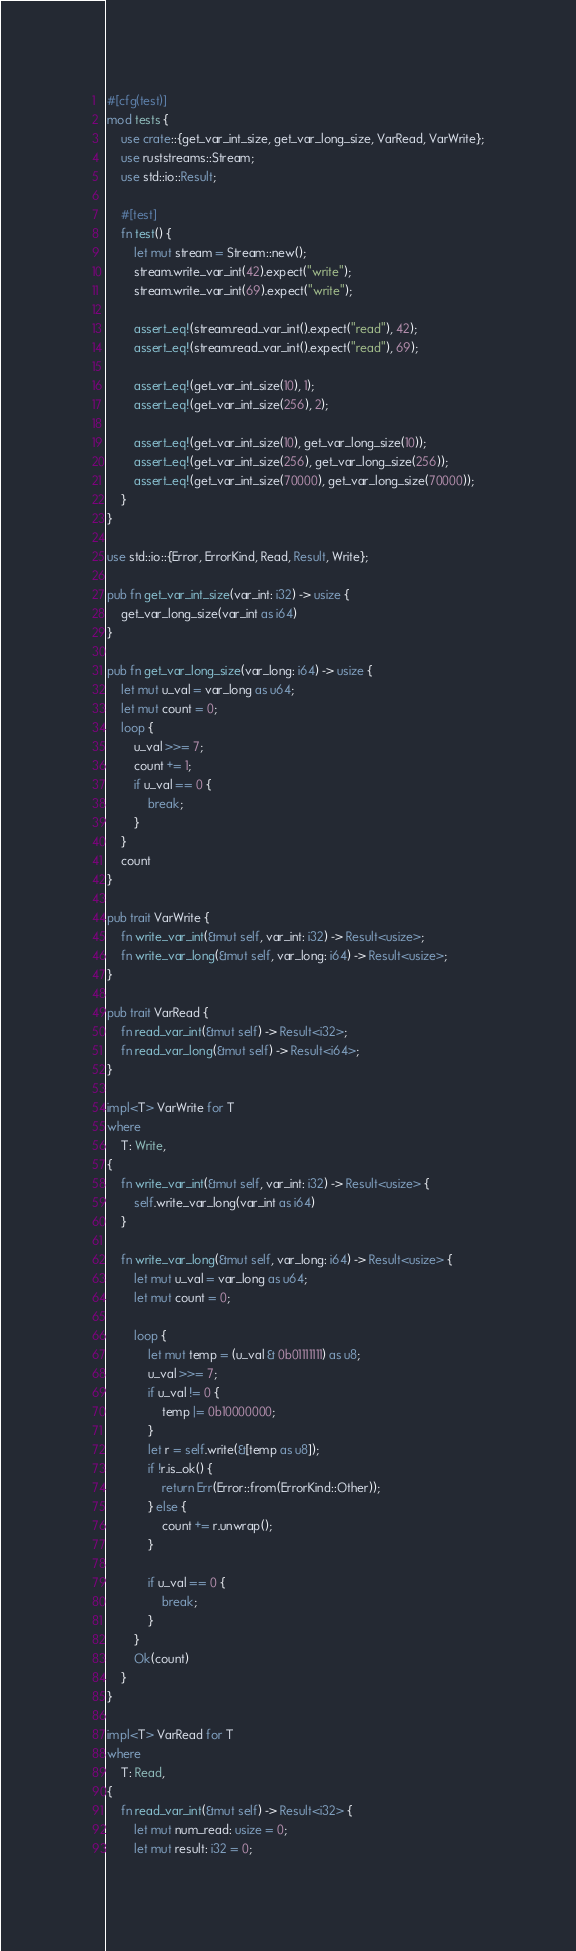<code> <loc_0><loc_0><loc_500><loc_500><_Rust_>#[cfg(test)]
mod tests {
    use crate::{get_var_int_size, get_var_long_size, VarRead, VarWrite};
    use ruststreams::Stream;
    use std::io::Result;

    #[test]
    fn test() {
        let mut stream = Stream::new();
        stream.write_var_int(42).expect("write");
        stream.write_var_int(69).expect("write");

        assert_eq!(stream.read_var_int().expect("read"), 42);
        assert_eq!(stream.read_var_int().expect("read"), 69);

        assert_eq!(get_var_int_size(10), 1);
        assert_eq!(get_var_int_size(256), 2);

        assert_eq!(get_var_int_size(10), get_var_long_size(10));
        assert_eq!(get_var_int_size(256), get_var_long_size(256));
        assert_eq!(get_var_int_size(70000), get_var_long_size(70000));
    }
}

use std::io::{Error, ErrorKind, Read, Result, Write};

pub fn get_var_int_size(var_int: i32) -> usize {
    get_var_long_size(var_int as i64)
}

pub fn get_var_long_size(var_long: i64) -> usize {
    let mut u_val = var_long as u64;
    let mut count = 0;
    loop {
        u_val >>= 7;
        count += 1;
        if u_val == 0 {
            break;
        }
    }
    count
}

pub trait VarWrite {
    fn write_var_int(&mut self, var_int: i32) -> Result<usize>;
    fn write_var_long(&mut self, var_long: i64) -> Result<usize>;
}

pub trait VarRead {
    fn read_var_int(&mut self) -> Result<i32>;
    fn read_var_long(&mut self) -> Result<i64>;
}

impl<T> VarWrite for T
where
    T: Write,
{
    fn write_var_int(&mut self, var_int: i32) -> Result<usize> {
        self.write_var_long(var_int as i64)
    }

    fn write_var_long(&mut self, var_long: i64) -> Result<usize> {
        let mut u_val = var_long as u64;
        let mut count = 0;

        loop {
            let mut temp = (u_val & 0b01111111) as u8;
            u_val >>= 7;
            if u_val != 0 {
                temp |= 0b10000000;
            }
            let r = self.write(&[temp as u8]);
            if !r.is_ok() {
                return Err(Error::from(ErrorKind::Other));
            } else {
                count += r.unwrap();
            }

            if u_val == 0 {
                break;
            }
        }
        Ok(count)
    }
}

impl<T> VarRead for T
where
    T: Read,
{
    fn read_var_int(&mut self) -> Result<i32> {
        let mut num_read: usize = 0;
        let mut result: i32 = 0;</code> 